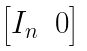<formula> <loc_0><loc_0><loc_500><loc_500>\begin{bmatrix} I _ { n } & 0 \end{bmatrix}</formula> 